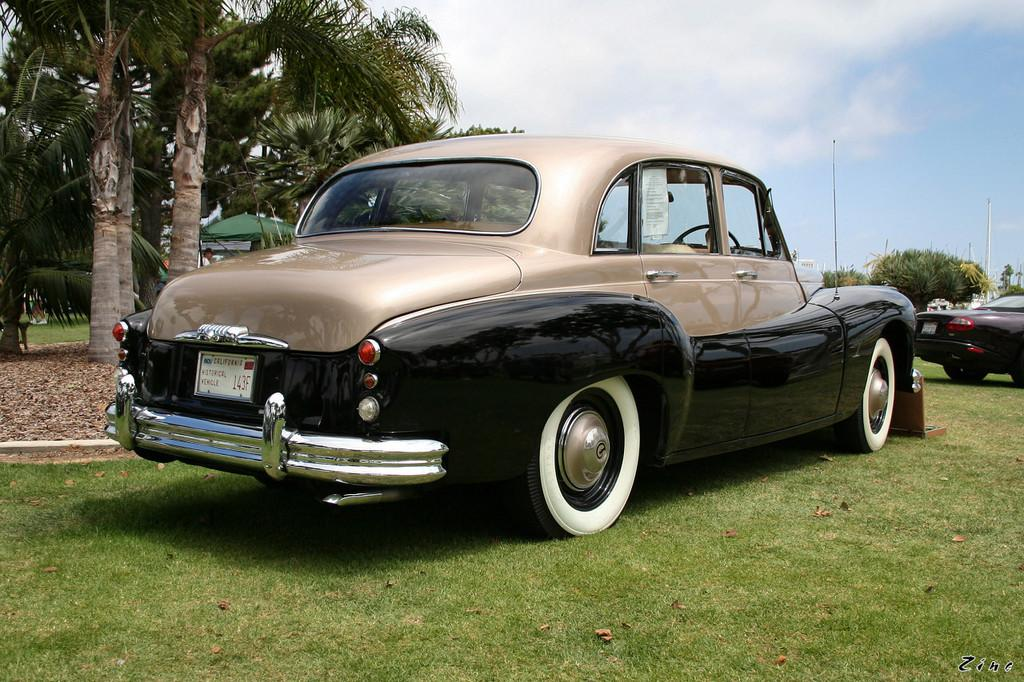What type of vehicles can be seen in the image? There are cars in the image. What is the ground surface like in the image? There is grass on the ground in the image. What can be seen in the background of the image? There are trees and the sky visible in the background of the image. What type of tax can be seen on the cars in the image? There is no mention of tax on the cars in the image, and therefore no such detail can be observed. 